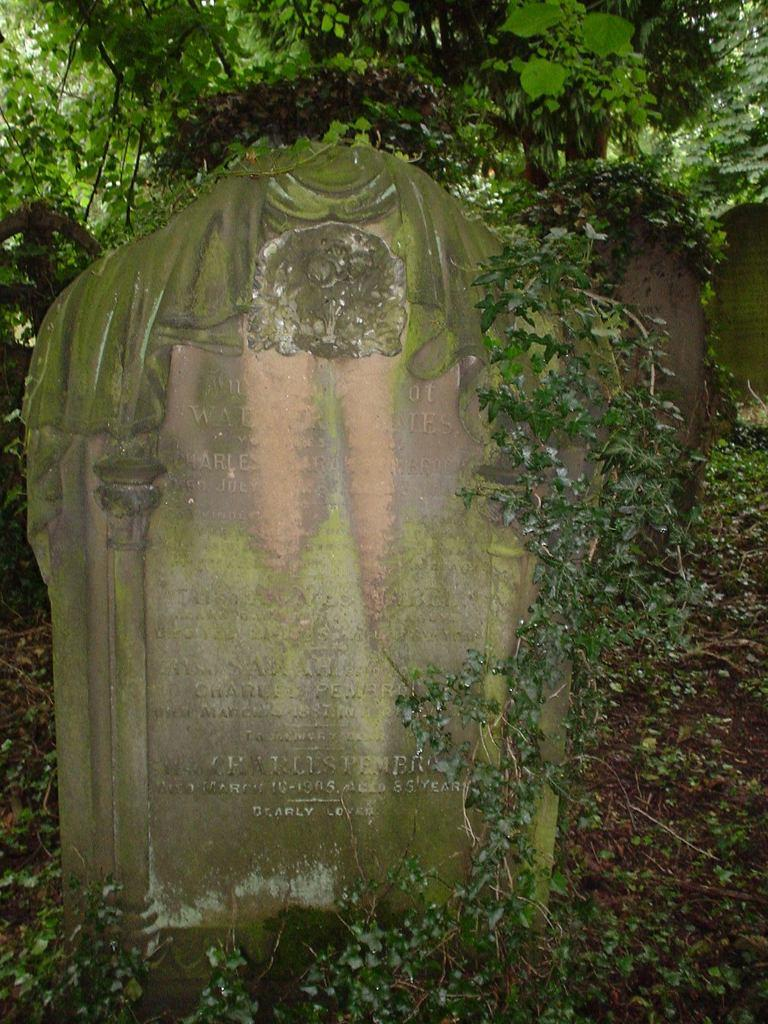What is the main object in the image? There is a stone in the image. What is written or depicted on the stone? There is text on the stone. What can be seen in the background of the image? There are plants in the background of the image. How many rivers can be seen flowing through the garden in the image? There is no garden or river present in the image; it features a stone with text and plants in the background. 